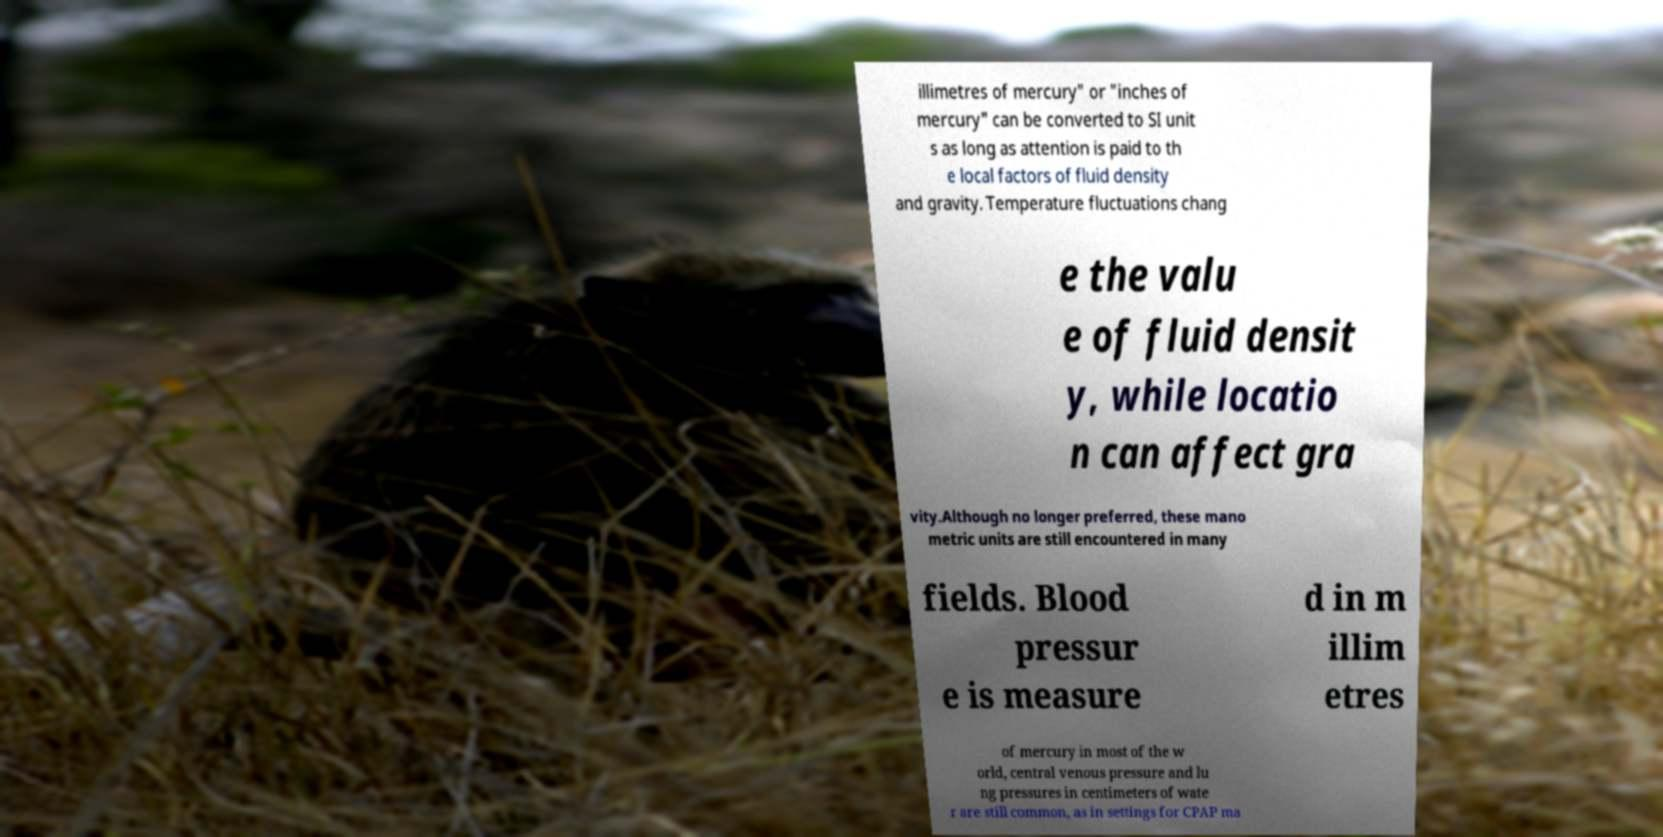Can you read and provide the text displayed in the image?This photo seems to have some interesting text. Can you extract and type it out for me? illimetres of mercury" or "inches of mercury" can be converted to SI unit s as long as attention is paid to th e local factors of fluid density and gravity. Temperature fluctuations chang e the valu e of fluid densit y, while locatio n can affect gra vity.Although no longer preferred, these mano metric units are still encountered in many fields. Blood pressur e is measure d in m illim etres of mercury in most of the w orld, central venous pressure and lu ng pressures in centimeters of wate r are still common, as in settings for CPAP ma 